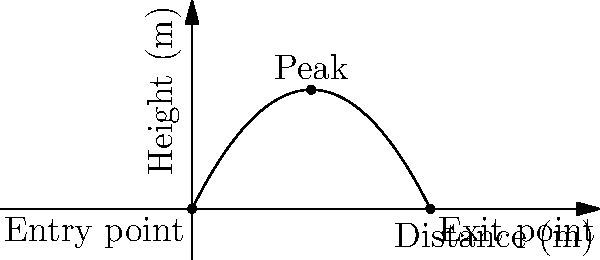A patient arrives at the ER with a projectile injury. The trajectory of the projectile through the body can be modeled by the quadratic function $h(x) = -0.05x^2 + 2x$, where $h$ is the height in meters and $x$ is the horizontal distance in meters. What is the maximum depth of penetration of the projectile? To find the maximum depth of penetration, we need to determine the highest point of the parabola:

1) The vertex of a parabola represents its highest point.
2) For a quadratic function in the form $f(x) = ax^2 + bx + c$, the x-coordinate of the vertex is given by $x = -\frac{b}{2a}$.
3) In this case, $a = -0.05$ and $b = 2$.
4) $x = -\frac{2}{2(-0.05)} = \frac{2}{0.1} = 20$ meters
5) To find the y-coordinate (height), we substitute this x-value into the original function:
   $h(20) = -0.05(20)^2 + 2(20) = -20 + 40 = 20$ meters
6) Therefore, the vertex is at the point (20, 20).

The maximum depth of penetration is the y-coordinate of this point, which is 20 meters.
Answer: 20 meters 